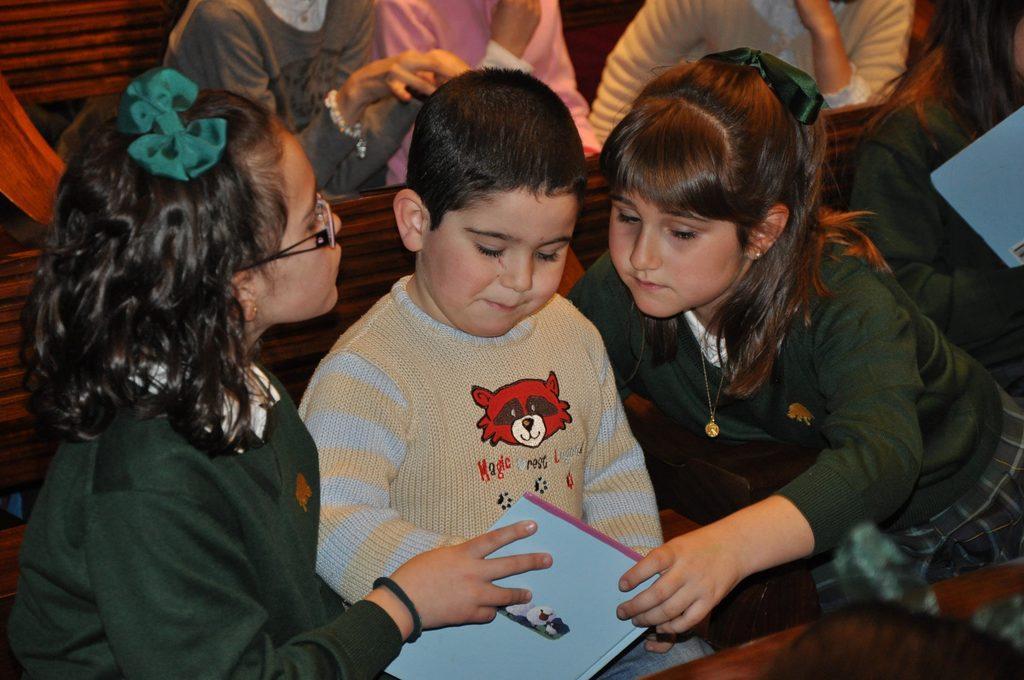How would you summarize this image in a sentence or two? In this picture we can see few kids and we can see a book at the bottom of the image. 